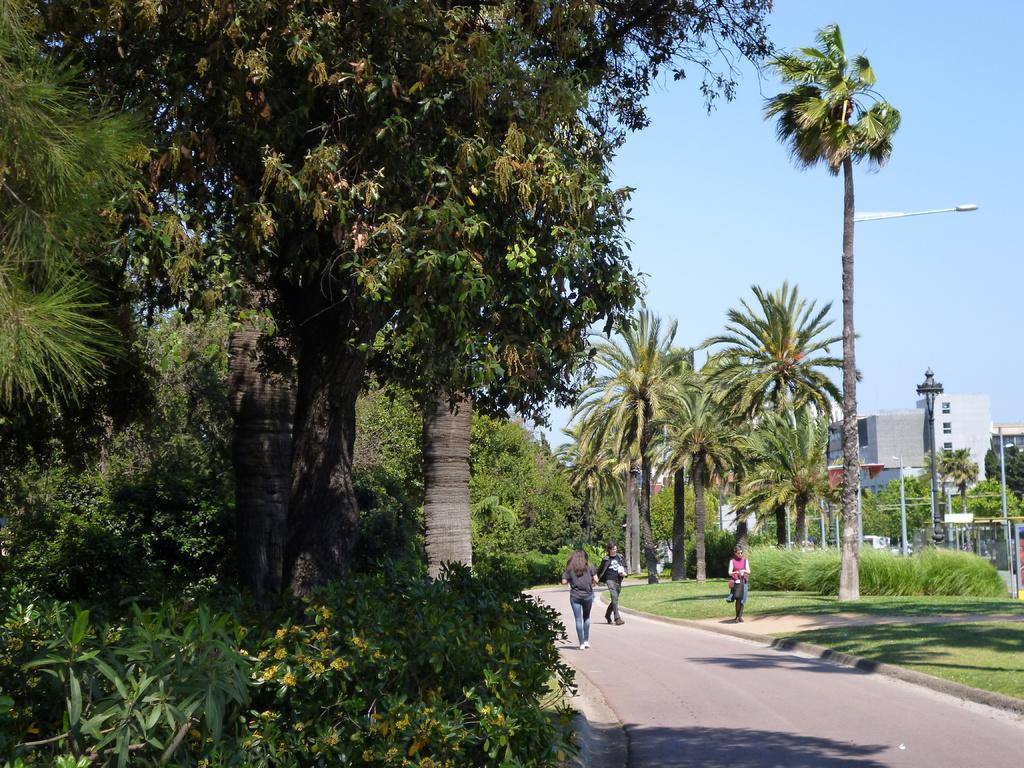Where was the image taken? The image was clicked outside. What can be seen in the image besides the persons walking? There are trees and buildings visible in the image. What is visible at the top of the image? The sky is visible at the top of the image. What theory is being discussed by the persons walking in the image? There is no indication in the image that the persons walking are discussing any theory. What symbol of peace can be seen in the image? There is no symbol of peace present in the image. 